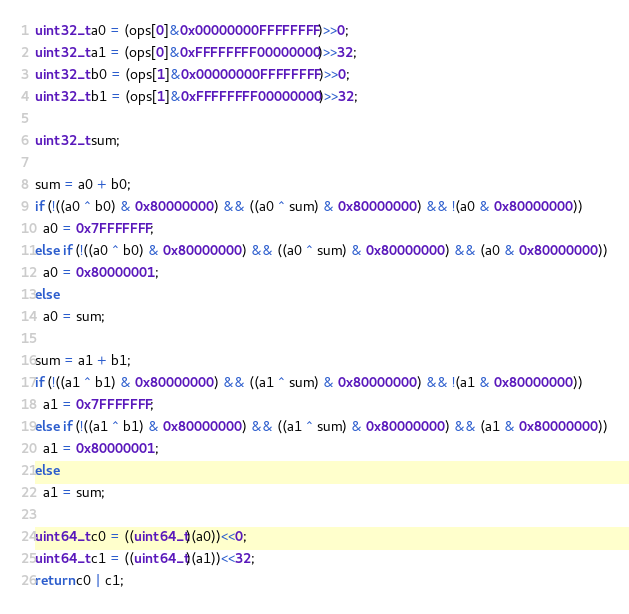<code> <loc_0><loc_0><loc_500><loc_500><_C_>uint32_t a0 = (ops[0]&0x00000000FFFFFFFF)>>0;
uint32_t a1 = (ops[0]&0xFFFFFFFF00000000)>>32;
uint32_t b0 = (ops[1]&0x00000000FFFFFFFF)>>0;
uint32_t b1 = (ops[1]&0xFFFFFFFF00000000)>>32;

uint32_t sum;

sum = a0 + b0;
if (!((a0 ^ b0) & 0x80000000) && ((a0 ^ sum) & 0x80000000) && !(a0 & 0x80000000))
  a0 = 0x7FFFFFFF;
else if (!((a0 ^ b0) & 0x80000000) && ((a0 ^ sum) & 0x80000000) && (a0 & 0x80000000))
  a0 = 0x80000001;
else
  a0 = sum;

sum = a1 + b1;
if (!((a1 ^ b1) & 0x80000000) && ((a1 ^ sum) & 0x80000000) && !(a1 & 0x80000000))
  a1 = 0x7FFFFFFF;
else if (!((a1 ^ b1) & 0x80000000) && ((a1 ^ sum) & 0x80000000) && (a1 & 0x80000000))
  a1 = 0x80000001;
else
  a1 = sum;

uint64_t c0 = ((uint64_t)(a0))<<0;
uint64_t c1 = ((uint64_t)(a1))<<32;
return c0 | c1;
</code> 